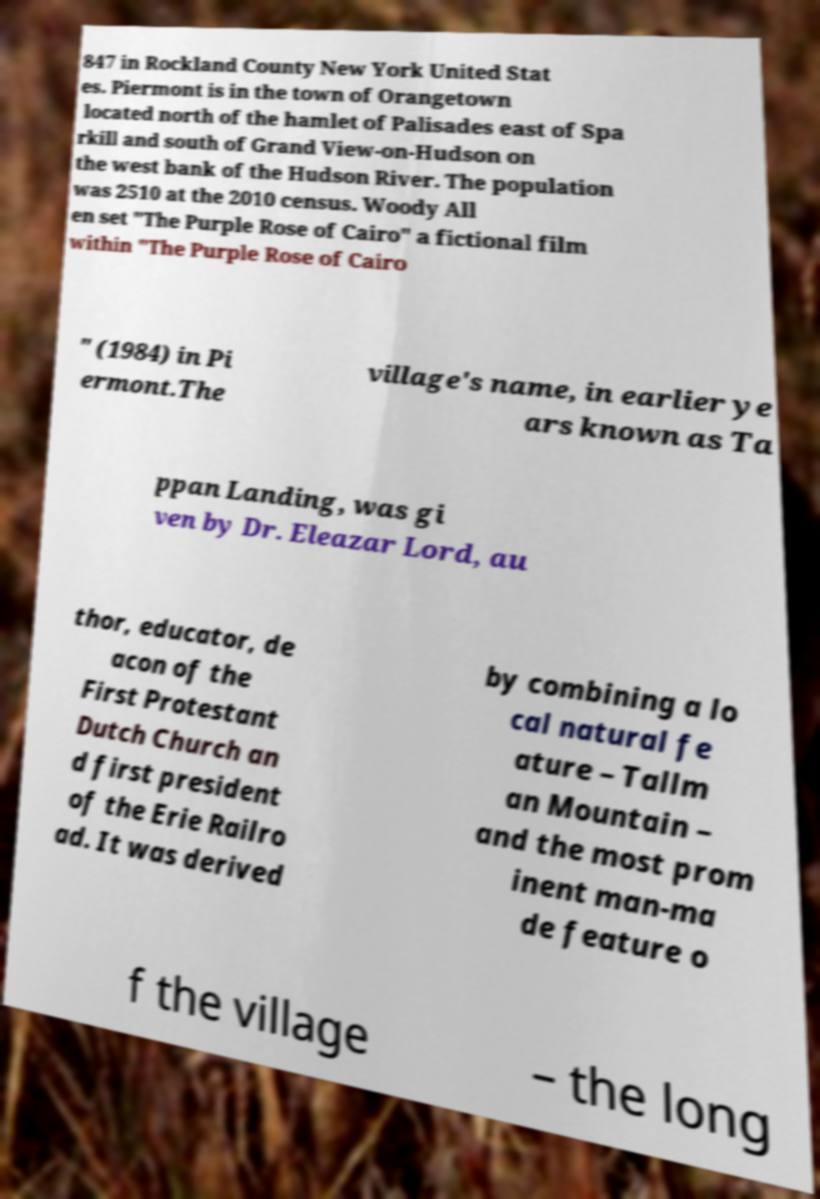Can you read and provide the text displayed in the image?This photo seems to have some interesting text. Can you extract and type it out for me? 847 in Rockland County New York United Stat es. Piermont is in the town of Orangetown located north of the hamlet of Palisades east of Spa rkill and south of Grand View-on-Hudson on the west bank of the Hudson River. The population was 2510 at the 2010 census. Woody All en set "The Purple Rose of Cairo" a fictional film within "The Purple Rose of Cairo " (1984) in Pi ermont.The village's name, in earlier ye ars known as Ta ppan Landing, was gi ven by Dr. Eleazar Lord, au thor, educator, de acon of the First Protestant Dutch Church an d first president of the Erie Railro ad. It was derived by combining a lo cal natural fe ature – Tallm an Mountain – and the most prom inent man-ma de feature o f the village – the long 